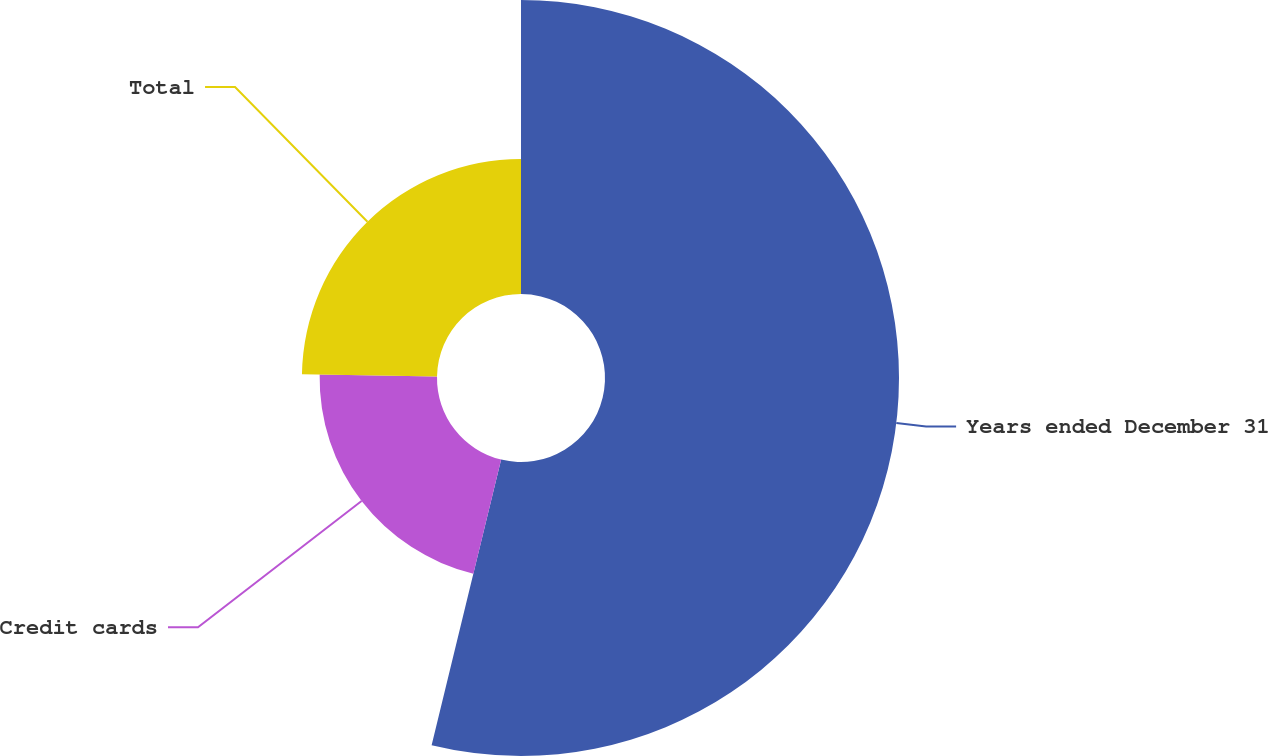Convert chart. <chart><loc_0><loc_0><loc_500><loc_500><pie_chart><fcel>Years ended December 31<fcel>Credit cards<fcel>Total<nl><fcel>53.8%<fcel>21.48%<fcel>24.72%<nl></chart> 